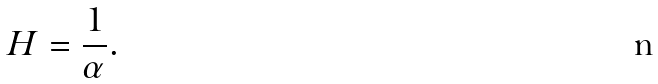Convert formula to latex. <formula><loc_0><loc_0><loc_500><loc_500>H = \frac { 1 } { \alpha } .</formula> 